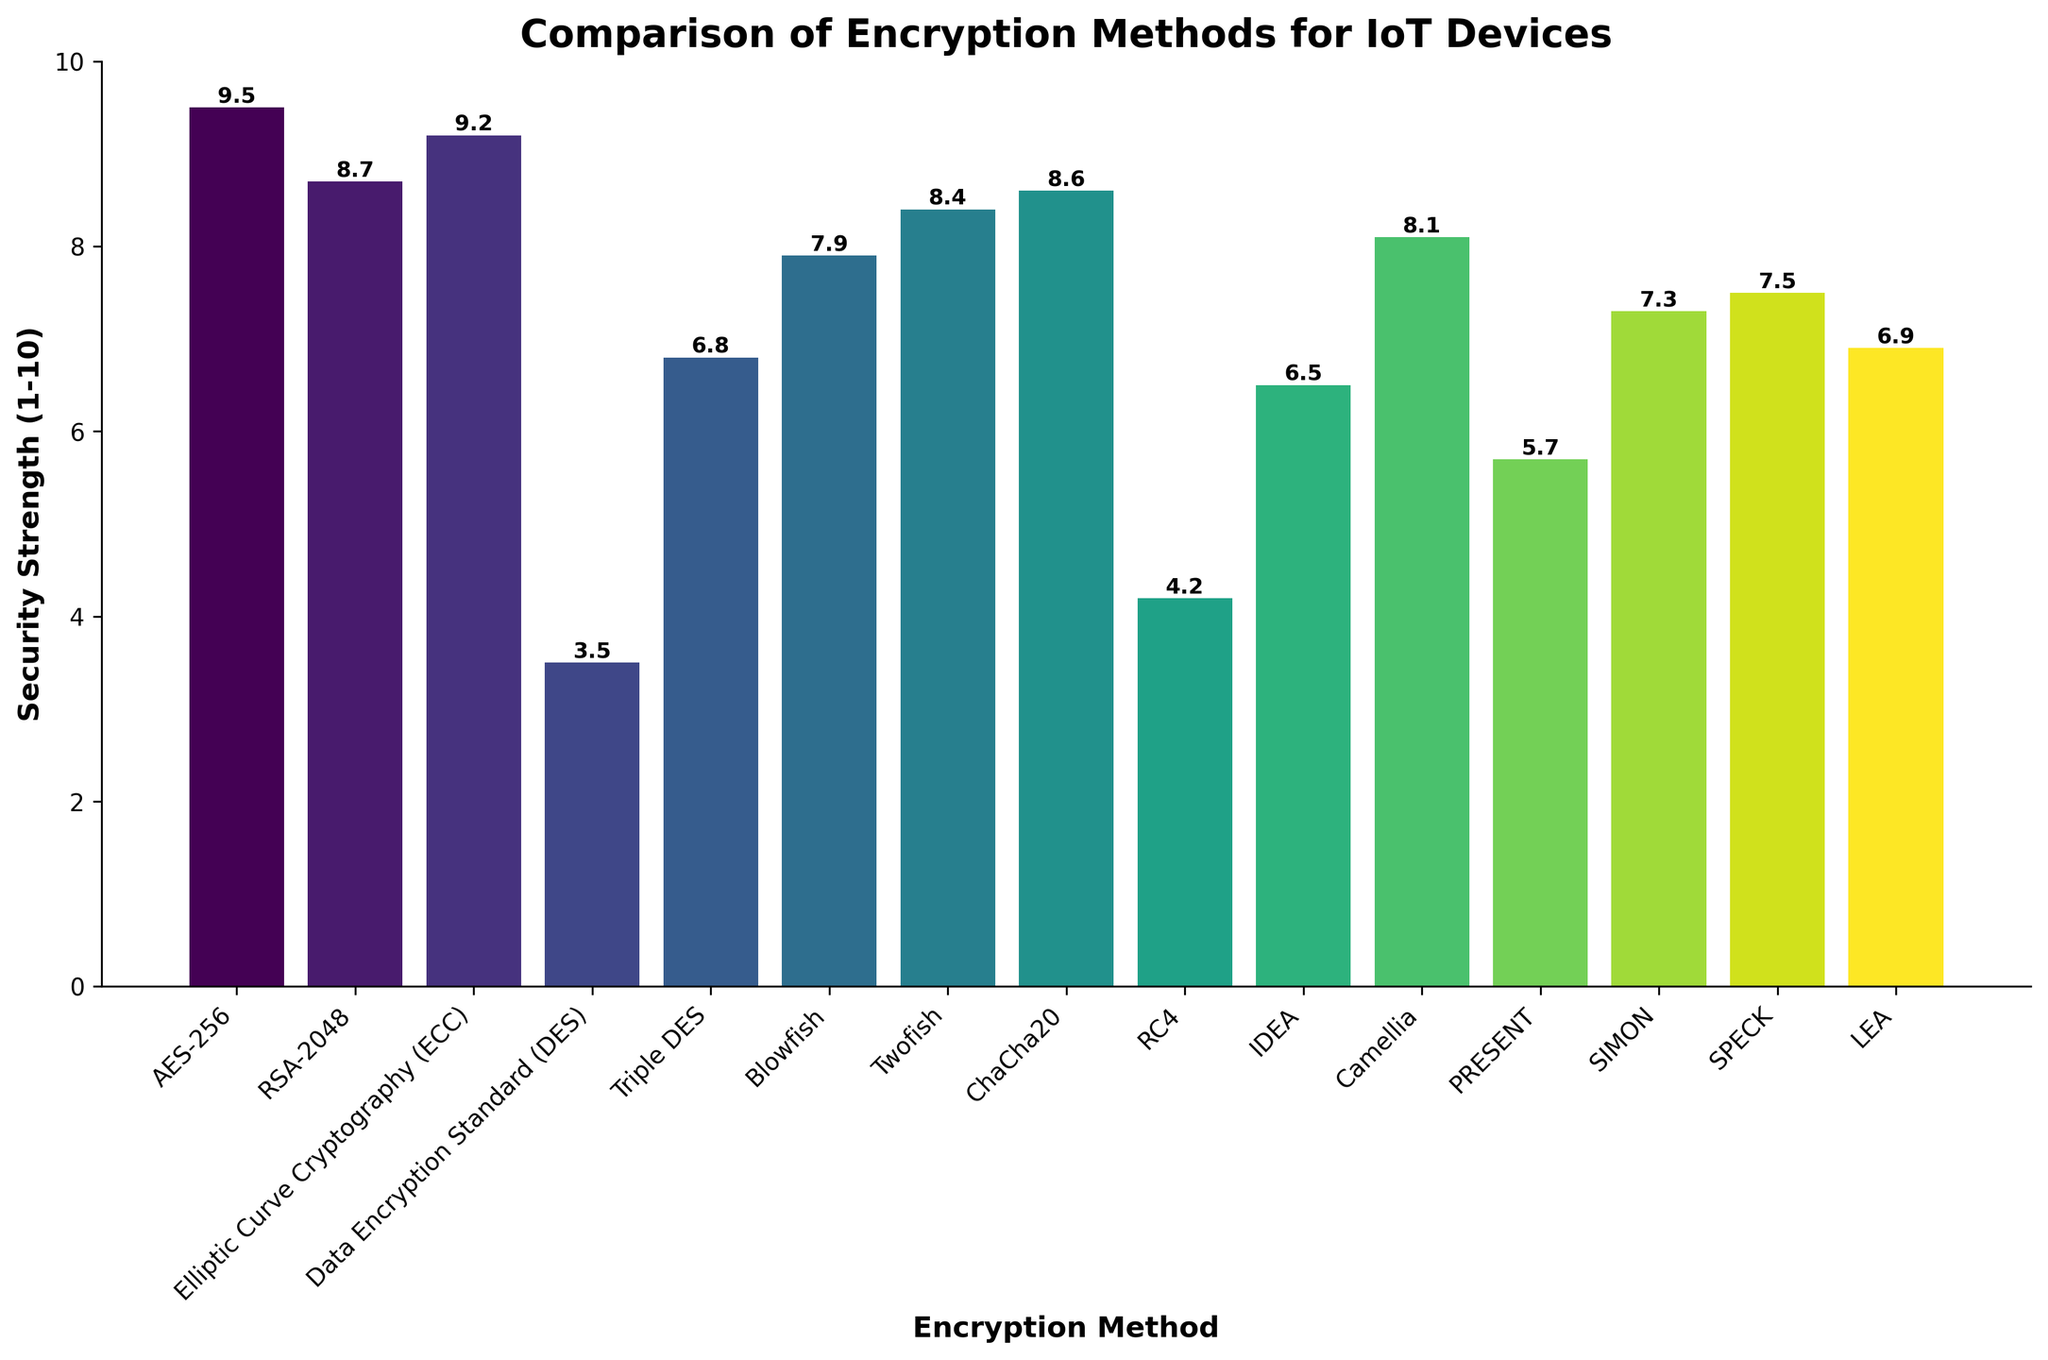What is the security strength of AES-256? Locate the bar representing AES-256 on the x-axis and read the value at the top of the bar. The height of the bar indicates the security strength.
Answer: 9.5 Which encryption method has the lowest security strength? Identify the shortest bar in the chart as it represents the lowest security strength. The label below this bar will indicate the encryption method.
Answer: Data Encryption Standard (DES) Compare the security strengths of RSA-2048 and ChaCha20. Which one is stronger? Locate the bars for RSA-2048 and ChaCha20, then compare their heights. RSA-2048 has a height of 8.7 and ChaCha20 has a height of 8.6.
Answer: RSA-2048 What is the difference in security strength between Blowfish and Triple DES? Find the heights of the bars for Blowfish and Triple DES. Subtract the height of Triple DES from Blowfish (Blowfish: 7.9, Triple DES: 6.8).
Answer: 1.1 Which encryption methods have a security strength greater than 8? Identify all bars that have heights greater than 8. The labels below these bars will indicate the encryption methods.
Answer: AES-256, RSA-2048, Elliptic Curve Cryptography (ECC), ChaCha20, Twofish What is the average security strength of the top 3 strongest encryption methods? Identify the top 3 tallest bars (AES-256, ECC, RSA-2048) and find their heights (9.5, 9.2, 8.7). Calculate the average: (9.5 + 9.2 + 8.7) / 3.
Answer: 9.13 Which encryption method is visually represented by the second tallest bar? Visually identify the second tallest bar, then read the label below it. The second tallest bar represents Elliptic Curve Cryptography (ECC).
Answer: Elliptic Curve Cryptography (ECC) What is the total sum of the security strengths for PRESENT, SIMON, and SPECK? Find the security strengths of PRESENT, SIMON, and SPECK (5.7, 7.3, 7.5). Sum them up: 5.7 + 7.3 + 7.5.
Answer: 20.5 How many encryption methods have a security strength less than 7? Count the number of bars with heights less than 7. The methods are DES, RC4, IDEA, PRESENT.
Answer: 4 